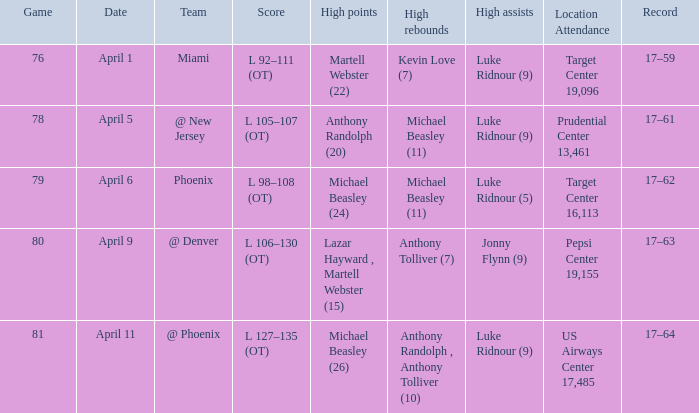Who secured the most elevated rebounds on april 6? Michael Beasley (11). Give me the full table as a dictionary. {'header': ['Game', 'Date', 'Team', 'Score', 'High points', 'High rebounds', 'High assists', 'Location Attendance', 'Record'], 'rows': [['76', 'April 1', 'Miami', 'L 92–111 (OT)', 'Martell Webster (22)', 'Kevin Love (7)', 'Luke Ridnour (9)', 'Target Center 19,096', '17–59'], ['78', 'April 5', '@ New Jersey', 'L 105–107 (OT)', 'Anthony Randolph (20)', 'Michael Beasley (11)', 'Luke Ridnour (9)', 'Prudential Center 13,461', '17–61'], ['79', 'April 6', 'Phoenix', 'L 98–108 (OT)', 'Michael Beasley (24)', 'Michael Beasley (11)', 'Luke Ridnour (5)', 'Target Center 16,113', '17–62'], ['80', 'April 9', '@ Denver', 'L 106–130 (OT)', 'Lazar Hayward , Martell Webster (15)', 'Anthony Tolliver (7)', 'Jonny Flynn (9)', 'Pepsi Center 19,155', '17–63'], ['81', 'April 11', '@ Phoenix', 'L 127–135 (OT)', 'Michael Beasley (26)', 'Anthony Randolph , Anthony Tolliver (10)', 'Luke Ridnour (9)', 'US Airways Center 17,485', '17–64']]} 